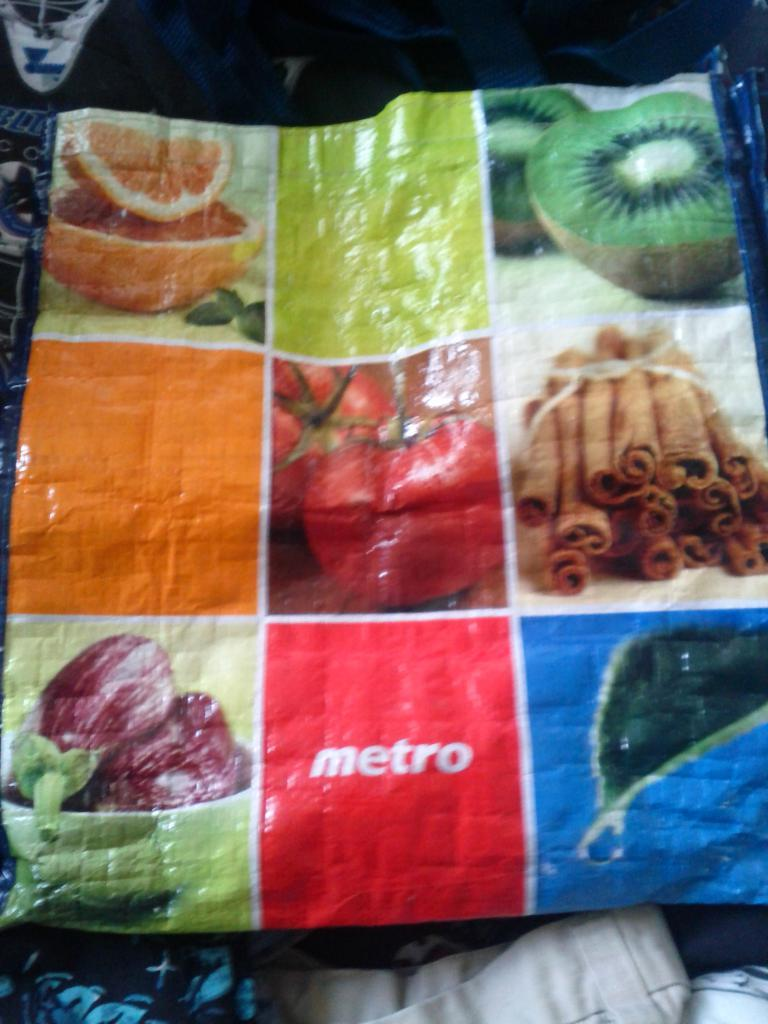What is present on the plastic cover in the image? There are photos on the plastic cover. Can you describe the plastic cover in the image? The plastic cover is transparent and has photos on it. How many books are being shaken by the person in the image? There is no person or books present in the image. 